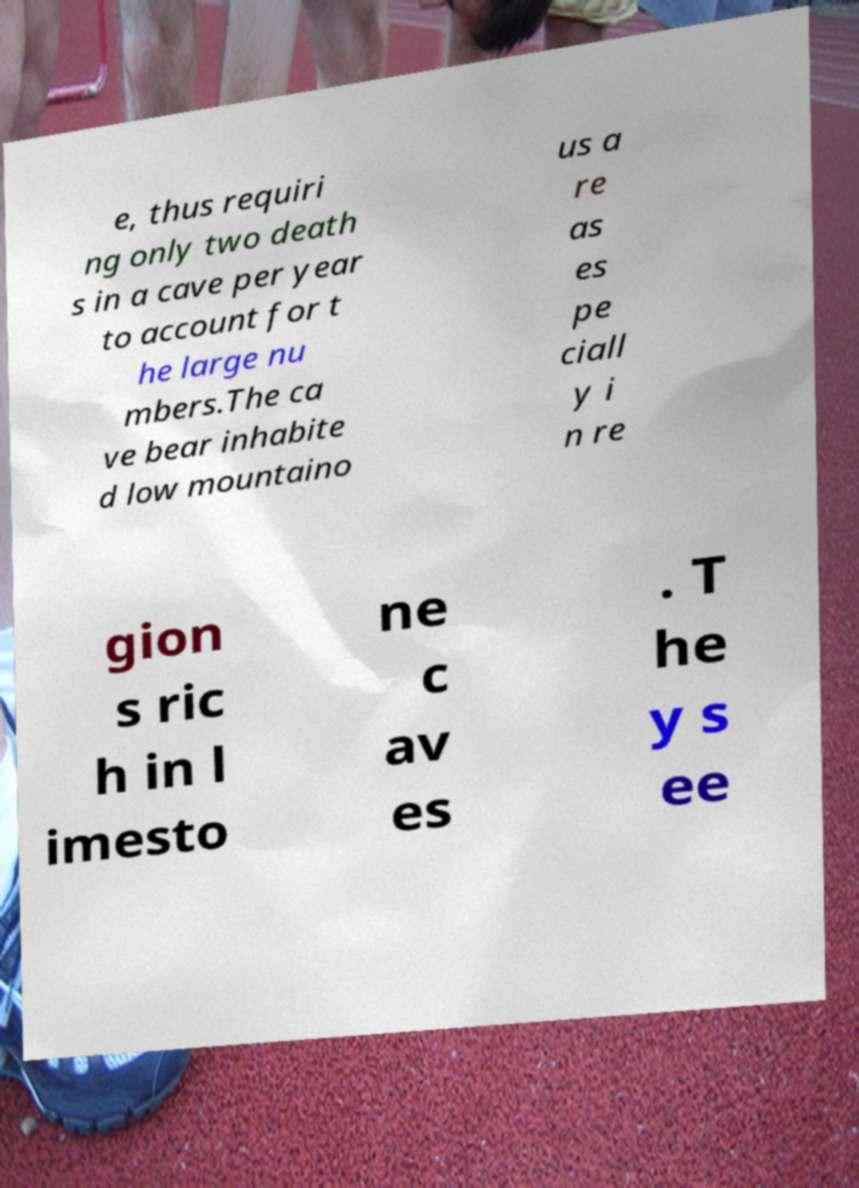I need the written content from this picture converted into text. Can you do that? e, thus requiri ng only two death s in a cave per year to account for t he large nu mbers.The ca ve bear inhabite d low mountaino us a re as es pe ciall y i n re gion s ric h in l imesto ne c av es . T he y s ee 